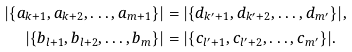Convert formula to latex. <formula><loc_0><loc_0><loc_500><loc_500>| \{ a _ { k + 1 } , a _ { k + 2 } , \dots , a _ { m + 1 } \} | & = | \{ d _ { k ^ { \prime } + 1 } , d _ { k ^ { \prime } + 2 } , \dots , d _ { m ^ { \prime } } \} | , \\ | \{ b _ { l + 1 } , b _ { l + 2 } , \dots , b _ { m } \} | & = | \{ c _ { l ^ { \prime } + 1 } , c _ { l ^ { \prime } + 2 } , \dots , c _ { m ^ { \prime } } \} | .</formula> 